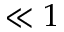<formula> <loc_0><loc_0><loc_500><loc_500>\ll 1</formula> 